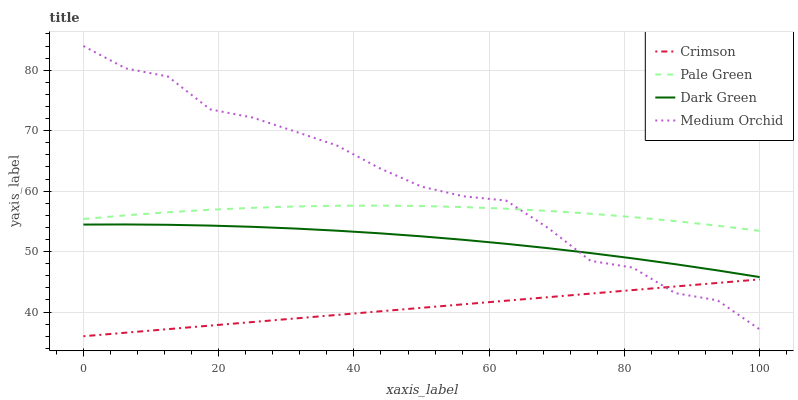Does Crimson have the minimum area under the curve?
Answer yes or no. Yes. Does Medium Orchid have the maximum area under the curve?
Answer yes or no. Yes. Does Pale Green have the minimum area under the curve?
Answer yes or no. No. Does Pale Green have the maximum area under the curve?
Answer yes or no. No. Is Crimson the smoothest?
Answer yes or no. Yes. Is Medium Orchid the roughest?
Answer yes or no. Yes. Is Pale Green the smoothest?
Answer yes or no. No. Is Pale Green the roughest?
Answer yes or no. No. Does Crimson have the lowest value?
Answer yes or no. Yes. Does Medium Orchid have the lowest value?
Answer yes or no. No. Does Medium Orchid have the highest value?
Answer yes or no. Yes. Does Pale Green have the highest value?
Answer yes or no. No. Is Crimson less than Pale Green?
Answer yes or no. Yes. Is Pale Green greater than Dark Green?
Answer yes or no. Yes. Does Dark Green intersect Medium Orchid?
Answer yes or no. Yes. Is Dark Green less than Medium Orchid?
Answer yes or no. No. Is Dark Green greater than Medium Orchid?
Answer yes or no. No. Does Crimson intersect Pale Green?
Answer yes or no. No. 